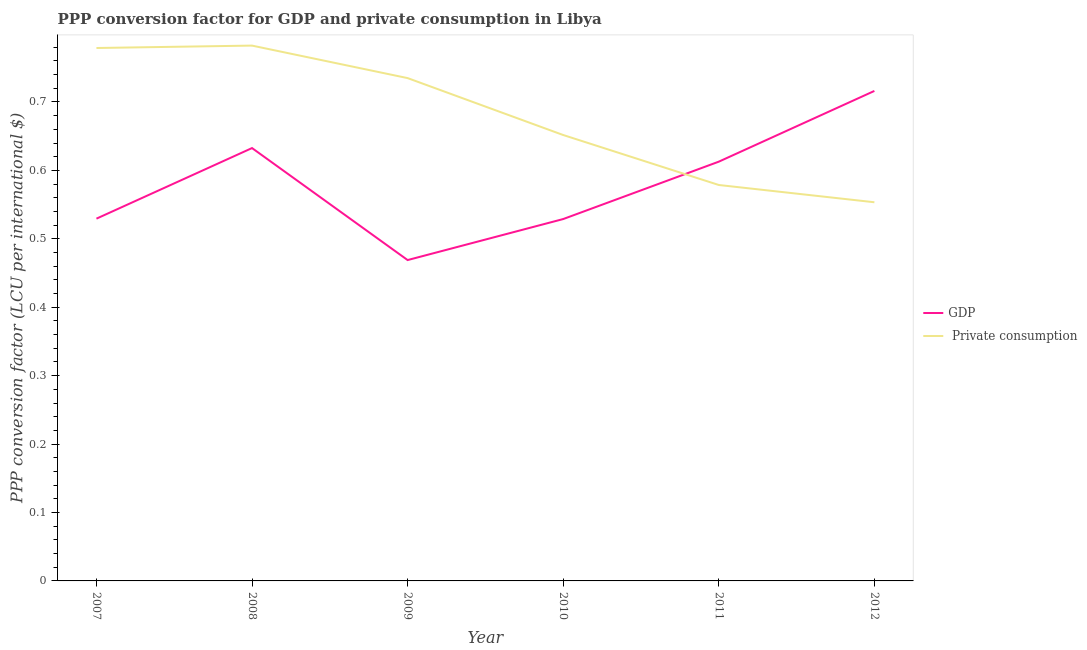Does the line corresponding to ppp conversion factor for private consumption intersect with the line corresponding to ppp conversion factor for gdp?
Your answer should be compact. Yes. Is the number of lines equal to the number of legend labels?
Give a very brief answer. Yes. What is the ppp conversion factor for private consumption in 2008?
Provide a succinct answer. 0.78. Across all years, what is the maximum ppp conversion factor for private consumption?
Your answer should be compact. 0.78. Across all years, what is the minimum ppp conversion factor for gdp?
Give a very brief answer. 0.47. What is the total ppp conversion factor for private consumption in the graph?
Ensure brevity in your answer.  4.08. What is the difference between the ppp conversion factor for gdp in 2009 and that in 2012?
Ensure brevity in your answer.  -0.25. What is the difference between the ppp conversion factor for gdp in 2012 and the ppp conversion factor for private consumption in 2011?
Offer a very short reply. 0.14. What is the average ppp conversion factor for private consumption per year?
Ensure brevity in your answer.  0.68. In the year 2012, what is the difference between the ppp conversion factor for private consumption and ppp conversion factor for gdp?
Give a very brief answer. -0.16. In how many years, is the ppp conversion factor for gdp greater than 0.1 LCU?
Provide a short and direct response. 6. What is the ratio of the ppp conversion factor for private consumption in 2007 to that in 2009?
Your answer should be compact. 1.06. Is the ppp conversion factor for private consumption in 2007 less than that in 2011?
Your response must be concise. No. What is the difference between the highest and the second highest ppp conversion factor for private consumption?
Your answer should be very brief. 0. What is the difference between the highest and the lowest ppp conversion factor for private consumption?
Offer a terse response. 0.23. Does the ppp conversion factor for gdp monotonically increase over the years?
Offer a very short reply. No. Is the ppp conversion factor for private consumption strictly greater than the ppp conversion factor for gdp over the years?
Make the answer very short. No. How many years are there in the graph?
Provide a short and direct response. 6. Does the graph contain grids?
Provide a succinct answer. No. How are the legend labels stacked?
Ensure brevity in your answer.  Vertical. What is the title of the graph?
Your response must be concise. PPP conversion factor for GDP and private consumption in Libya. What is the label or title of the X-axis?
Provide a succinct answer. Year. What is the label or title of the Y-axis?
Make the answer very short. PPP conversion factor (LCU per international $). What is the PPP conversion factor (LCU per international $) of GDP in 2007?
Make the answer very short. 0.53. What is the PPP conversion factor (LCU per international $) in  Private consumption in 2007?
Offer a terse response. 0.78. What is the PPP conversion factor (LCU per international $) in GDP in 2008?
Offer a very short reply. 0.63. What is the PPP conversion factor (LCU per international $) in  Private consumption in 2008?
Your answer should be very brief. 0.78. What is the PPP conversion factor (LCU per international $) in GDP in 2009?
Your answer should be very brief. 0.47. What is the PPP conversion factor (LCU per international $) in  Private consumption in 2009?
Keep it short and to the point. 0.73. What is the PPP conversion factor (LCU per international $) in GDP in 2010?
Ensure brevity in your answer.  0.53. What is the PPP conversion factor (LCU per international $) of  Private consumption in 2010?
Offer a terse response. 0.65. What is the PPP conversion factor (LCU per international $) of GDP in 2011?
Provide a succinct answer. 0.61. What is the PPP conversion factor (LCU per international $) in  Private consumption in 2011?
Offer a terse response. 0.58. What is the PPP conversion factor (LCU per international $) in GDP in 2012?
Give a very brief answer. 0.72. What is the PPP conversion factor (LCU per international $) in  Private consumption in 2012?
Provide a succinct answer. 0.55. Across all years, what is the maximum PPP conversion factor (LCU per international $) of GDP?
Make the answer very short. 0.72. Across all years, what is the maximum PPP conversion factor (LCU per international $) in  Private consumption?
Make the answer very short. 0.78. Across all years, what is the minimum PPP conversion factor (LCU per international $) of GDP?
Your response must be concise. 0.47. Across all years, what is the minimum PPP conversion factor (LCU per international $) of  Private consumption?
Your answer should be compact. 0.55. What is the total PPP conversion factor (LCU per international $) of GDP in the graph?
Your answer should be compact. 3.49. What is the total PPP conversion factor (LCU per international $) of  Private consumption in the graph?
Offer a very short reply. 4.08. What is the difference between the PPP conversion factor (LCU per international $) of GDP in 2007 and that in 2008?
Provide a succinct answer. -0.1. What is the difference between the PPP conversion factor (LCU per international $) in  Private consumption in 2007 and that in 2008?
Offer a very short reply. -0. What is the difference between the PPP conversion factor (LCU per international $) in GDP in 2007 and that in 2009?
Your answer should be compact. 0.06. What is the difference between the PPP conversion factor (LCU per international $) of  Private consumption in 2007 and that in 2009?
Your answer should be compact. 0.04. What is the difference between the PPP conversion factor (LCU per international $) of GDP in 2007 and that in 2010?
Your response must be concise. 0. What is the difference between the PPP conversion factor (LCU per international $) in  Private consumption in 2007 and that in 2010?
Offer a terse response. 0.13. What is the difference between the PPP conversion factor (LCU per international $) in GDP in 2007 and that in 2011?
Keep it short and to the point. -0.08. What is the difference between the PPP conversion factor (LCU per international $) of  Private consumption in 2007 and that in 2011?
Make the answer very short. 0.2. What is the difference between the PPP conversion factor (LCU per international $) of GDP in 2007 and that in 2012?
Offer a very short reply. -0.19. What is the difference between the PPP conversion factor (LCU per international $) in  Private consumption in 2007 and that in 2012?
Your answer should be very brief. 0.23. What is the difference between the PPP conversion factor (LCU per international $) of GDP in 2008 and that in 2009?
Provide a succinct answer. 0.16. What is the difference between the PPP conversion factor (LCU per international $) of  Private consumption in 2008 and that in 2009?
Make the answer very short. 0.05. What is the difference between the PPP conversion factor (LCU per international $) in GDP in 2008 and that in 2010?
Make the answer very short. 0.1. What is the difference between the PPP conversion factor (LCU per international $) of  Private consumption in 2008 and that in 2010?
Keep it short and to the point. 0.13. What is the difference between the PPP conversion factor (LCU per international $) in GDP in 2008 and that in 2011?
Ensure brevity in your answer.  0.02. What is the difference between the PPP conversion factor (LCU per international $) of  Private consumption in 2008 and that in 2011?
Provide a short and direct response. 0.2. What is the difference between the PPP conversion factor (LCU per international $) in GDP in 2008 and that in 2012?
Offer a terse response. -0.08. What is the difference between the PPP conversion factor (LCU per international $) in  Private consumption in 2008 and that in 2012?
Give a very brief answer. 0.23. What is the difference between the PPP conversion factor (LCU per international $) of GDP in 2009 and that in 2010?
Your response must be concise. -0.06. What is the difference between the PPP conversion factor (LCU per international $) of  Private consumption in 2009 and that in 2010?
Your answer should be very brief. 0.08. What is the difference between the PPP conversion factor (LCU per international $) of GDP in 2009 and that in 2011?
Your response must be concise. -0.14. What is the difference between the PPP conversion factor (LCU per international $) in  Private consumption in 2009 and that in 2011?
Your response must be concise. 0.16. What is the difference between the PPP conversion factor (LCU per international $) of GDP in 2009 and that in 2012?
Your response must be concise. -0.25. What is the difference between the PPP conversion factor (LCU per international $) of  Private consumption in 2009 and that in 2012?
Your answer should be very brief. 0.18. What is the difference between the PPP conversion factor (LCU per international $) of GDP in 2010 and that in 2011?
Your answer should be compact. -0.08. What is the difference between the PPP conversion factor (LCU per international $) of  Private consumption in 2010 and that in 2011?
Offer a very short reply. 0.07. What is the difference between the PPP conversion factor (LCU per international $) of GDP in 2010 and that in 2012?
Offer a terse response. -0.19. What is the difference between the PPP conversion factor (LCU per international $) in  Private consumption in 2010 and that in 2012?
Offer a terse response. 0.1. What is the difference between the PPP conversion factor (LCU per international $) in GDP in 2011 and that in 2012?
Offer a terse response. -0.1. What is the difference between the PPP conversion factor (LCU per international $) in  Private consumption in 2011 and that in 2012?
Provide a short and direct response. 0.03. What is the difference between the PPP conversion factor (LCU per international $) in GDP in 2007 and the PPP conversion factor (LCU per international $) in  Private consumption in 2008?
Make the answer very short. -0.25. What is the difference between the PPP conversion factor (LCU per international $) in GDP in 2007 and the PPP conversion factor (LCU per international $) in  Private consumption in 2009?
Make the answer very short. -0.21. What is the difference between the PPP conversion factor (LCU per international $) of GDP in 2007 and the PPP conversion factor (LCU per international $) of  Private consumption in 2010?
Keep it short and to the point. -0.12. What is the difference between the PPP conversion factor (LCU per international $) of GDP in 2007 and the PPP conversion factor (LCU per international $) of  Private consumption in 2011?
Your answer should be compact. -0.05. What is the difference between the PPP conversion factor (LCU per international $) in GDP in 2007 and the PPP conversion factor (LCU per international $) in  Private consumption in 2012?
Provide a short and direct response. -0.02. What is the difference between the PPP conversion factor (LCU per international $) in GDP in 2008 and the PPP conversion factor (LCU per international $) in  Private consumption in 2009?
Ensure brevity in your answer.  -0.1. What is the difference between the PPP conversion factor (LCU per international $) of GDP in 2008 and the PPP conversion factor (LCU per international $) of  Private consumption in 2010?
Provide a succinct answer. -0.02. What is the difference between the PPP conversion factor (LCU per international $) in GDP in 2008 and the PPP conversion factor (LCU per international $) in  Private consumption in 2011?
Ensure brevity in your answer.  0.05. What is the difference between the PPP conversion factor (LCU per international $) of GDP in 2008 and the PPP conversion factor (LCU per international $) of  Private consumption in 2012?
Ensure brevity in your answer.  0.08. What is the difference between the PPP conversion factor (LCU per international $) in GDP in 2009 and the PPP conversion factor (LCU per international $) in  Private consumption in 2010?
Your answer should be compact. -0.18. What is the difference between the PPP conversion factor (LCU per international $) in GDP in 2009 and the PPP conversion factor (LCU per international $) in  Private consumption in 2011?
Provide a short and direct response. -0.11. What is the difference between the PPP conversion factor (LCU per international $) in GDP in 2009 and the PPP conversion factor (LCU per international $) in  Private consumption in 2012?
Your answer should be compact. -0.08. What is the difference between the PPP conversion factor (LCU per international $) of GDP in 2010 and the PPP conversion factor (LCU per international $) of  Private consumption in 2011?
Your response must be concise. -0.05. What is the difference between the PPP conversion factor (LCU per international $) in GDP in 2010 and the PPP conversion factor (LCU per international $) in  Private consumption in 2012?
Your response must be concise. -0.02. What is the difference between the PPP conversion factor (LCU per international $) in GDP in 2011 and the PPP conversion factor (LCU per international $) in  Private consumption in 2012?
Provide a succinct answer. 0.06. What is the average PPP conversion factor (LCU per international $) in GDP per year?
Offer a terse response. 0.58. What is the average PPP conversion factor (LCU per international $) of  Private consumption per year?
Make the answer very short. 0.68. In the year 2007, what is the difference between the PPP conversion factor (LCU per international $) of GDP and PPP conversion factor (LCU per international $) of  Private consumption?
Provide a succinct answer. -0.25. In the year 2008, what is the difference between the PPP conversion factor (LCU per international $) of GDP and PPP conversion factor (LCU per international $) of  Private consumption?
Offer a very short reply. -0.15. In the year 2009, what is the difference between the PPP conversion factor (LCU per international $) of GDP and PPP conversion factor (LCU per international $) of  Private consumption?
Offer a terse response. -0.27. In the year 2010, what is the difference between the PPP conversion factor (LCU per international $) in GDP and PPP conversion factor (LCU per international $) in  Private consumption?
Your answer should be compact. -0.12. In the year 2011, what is the difference between the PPP conversion factor (LCU per international $) in GDP and PPP conversion factor (LCU per international $) in  Private consumption?
Make the answer very short. 0.03. In the year 2012, what is the difference between the PPP conversion factor (LCU per international $) of GDP and PPP conversion factor (LCU per international $) of  Private consumption?
Offer a very short reply. 0.16. What is the ratio of the PPP conversion factor (LCU per international $) in GDP in 2007 to that in 2008?
Offer a very short reply. 0.84. What is the ratio of the PPP conversion factor (LCU per international $) of GDP in 2007 to that in 2009?
Offer a terse response. 1.13. What is the ratio of the PPP conversion factor (LCU per international $) in  Private consumption in 2007 to that in 2009?
Keep it short and to the point. 1.06. What is the ratio of the PPP conversion factor (LCU per international $) in  Private consumption in 2007 to that in 2010?
Your answer should be compact. 1.2. What is the ratio of the PPP conversion factor (LCU per international $) of GDP in 2007 to that in 2011?
Your answer should be compact. 0.86. What is the ratio of the PPP conversion factor (LCU per international $) of  Private consumption in 2007 to that in 2011?
Your answer should be compact. 1.35. What is the ratio of the PPP conversion factor (LCU per international $) in GDP in 2007 to that in 2012?
Keep it short and to the point. 0.74. What is the ratio of the PPP conversion factor (LCU per international $) of  Private consumption in 2007 to that in 2012?
Provide a short and direct response. 1.41. What is the ratio of the PPP conversion factor (LCU per international $) of GDP in 2008 to that in 2009?
Keep it short and to the point. 1.35. What is the ratio of the PPP conversion factor (LCU per international $) of  Private consumption in 2008 to that in 2009?
Your response must be concise. 1.06. What is the ratio of the PPP conversion factor (LCU per international $) in GDP in 2008 to that in 2010?
Offer a very short reply. 1.2. What is the ratio of the PPP conversion factor (LCU per international $) of  Private consumption in 2008 to that in 2010?
Provide a short and direct response. 1.2. What is the ratio of the PPP conversion factor (LCU per international $) in GDP in 2008 to that in 2011?
Your answer should be very brief. 1.03. What is the ratio of the PPP conversion factor (LCU per international $) in  Private consumption in 2008 to that in 2011?
Your answer should be very brief. 1.35. What is the ratio of the PPP conversion factor (LCU per international $) in GDP in 2008 to that in 2012?
Provide a succinct answer. 0.88. What is the ratio of the PPP conversion factor (LCU per international $) of  Private consumption in 2008 to that in 2012?
Your response must be concise. 1.41. What is the ratio of the PPP conversion factor (LCU per international $) of GDP in 2009 to that in 2010?
Your answer should be very brief. 0.89. What is the ratio of the PPP conversion factor (LCU per international $) in  Private consumption in 2009 to that in 2010?
Offer a terse response. 1.13. What is the ratio of the PPP conversion factor (LCU per international $) of GDP in 2009 to that in 2011?
Offer a terse response. 0.77. What is the ratio of the PPP conversion factor (LCU per international $) of  Private consumption in 2009 to that in 2011?
Your answer should be compact. 1.27. What is the ratio of the PPP conversion factor (LCU per international $) of GDP in 2009 to that in 2012?
Offer a very short reply. 0.65. What is the ratio of the PPP conversion factor (LCU per international $) in  Private consumption in 2009 to that in 2012?
Keep it short and to the point. 1.33. What is the ratio of the PPP conversion factor (LCU per international $) in GDP in 2010 to that in 2011?
Ensure brevity in your answer.  0.86. What is the ratio of the PPP conversion factor (LCU per international $) of  Private consumption in 2010 to that in 2011?
Make the answer very short. 1.13. What is the ratio of the PPP conversion factor (LCU per international $) in GDP in 2010 to that in 2012?
Ensure brevity in your answer.  0.74. What is the ratio of the PPP conversion factor (LCU per international $) in  Private consumption in 2010 to that in 2012?
Provide a succinct answer. 1.18. What is the ratio of the PPP conversion factor (LCU per international $) of GDP in 2011 to that in 2012?
Your response must be concise. 0.86. What is the ratio of the PPP conversion factor (LCU per international $) of  Private consumption in 2011 to that in 2012?
Keep it short and to the point. 1.05. What is the difference between the highest and the second highest PPP conversion factor (LCU per international $) in GDP?
Offer a very short reply. 0.08. What is the difference between the highest and the second highest PPP conversion factor (LCU per international $) in  Private consumption?
Offer a very short reply. 0. What is the difference between the highest and the lowest PPP conversion factor (LCU per international $) in GDP?
Offer a very short reply. 0.25. What is the difference between the highest and the lowest PPP conversion factor (LCU per international $) in  Private consumption?
Provide a short and direct response. 0.23. 